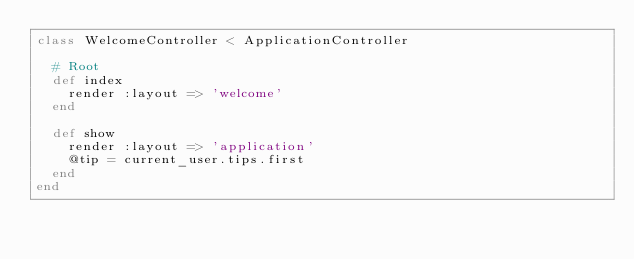Convert code to text. <code><loc_0><loc_0><loc_500><loc_500><_Ruby_>class WelcomeController < ApplicationController

  # Root
  def index
    render :layout => 'welcome'
  end

  def show
    render :layout => 'application'
    @tip = current_user.tips.first
  end
end
</code> 